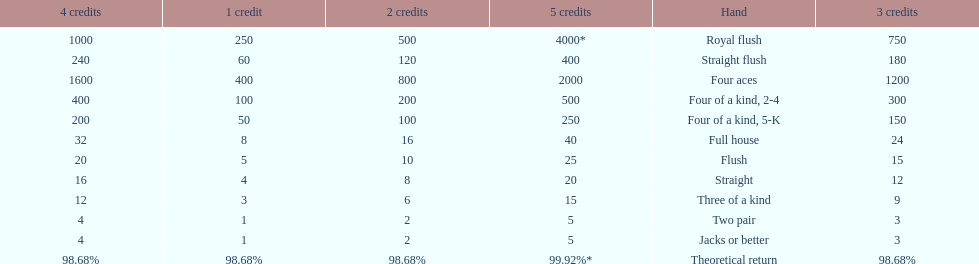What's the best type of four of a kind to win? Four of a kind, 2-4. 